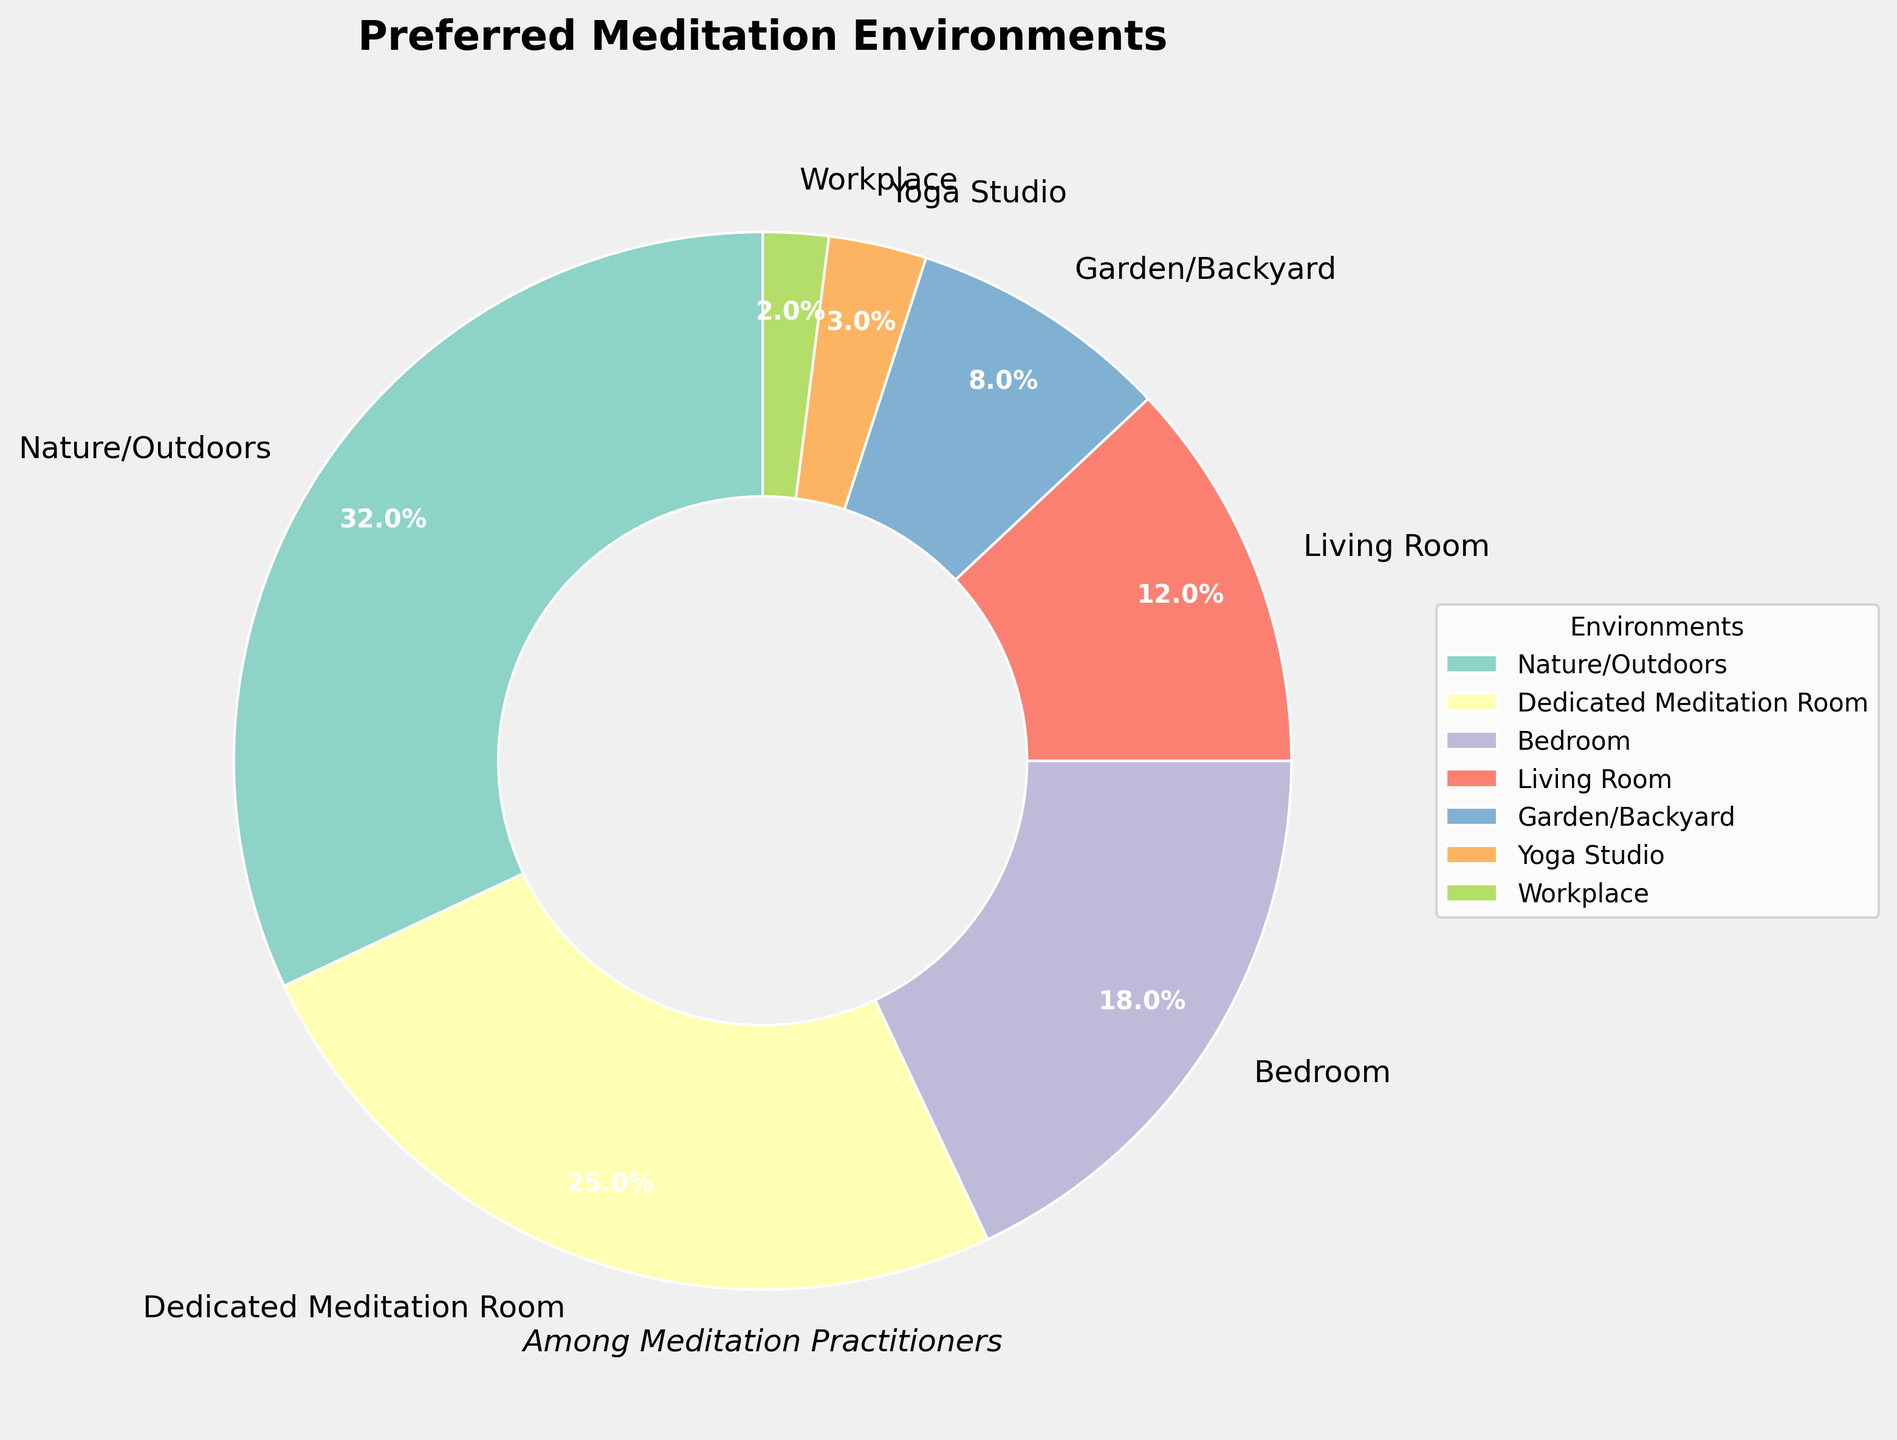Which meditation environment is preferred by the highest percentage of practitioners? The figure shows various meditation environments along with their corresponding percentages. The highest percentage is indicated by the largest slice of the pie chart.
Answer: Nature/Outdoors What is the combined percentage of practitioners who prefer meditating in their bedroom and living room? To find the combined percentage, sum the percentages of the 'Bedroom' and 'Living Room' slices. The figure shows these as 18% and 12%, respectively. So, 18% + 12% = 30%.
Answer: 30% Which is more popular, meditating in a garden/backyard or in a yoga studio? By comparing the sizes of the slices labeled 'Garden/Backyard' and 'Yoga Studio,' we can see that 'Garden/Backyard' is 8% and 'Yoga Studio' is 3%.
Answer: Garden/Backyard What is the difference in popularity between the least and most preferred meditation environments? The most preferred environment is 'Nature/Outdoors' at 32% and the least preferred is 'Workplace' at 2%. The difference is 32% - 2%.
Answer: 30% What percentage of practitioners prefer indoor environments for meditation? To find this, sum the percentages of indoor environments: 'Dedicated Meditation Room' (25%), 'Bedroom' (18%), 'Living Room' (12%), 'Yoga Studio' (3%), and 'Workplace' (2%). Therefore, 25% + 18% + 12% + 3% + 2% = 60%.
Answer: 60% How does the preference for a dedicated meditation room compare to the preference for a yoga studio? The slice for 'Dedicated Meditation Room' shows a percentage of 25%, whereas 'Yoga Studio' is 3%. This indicates that the dedicated meditation room is much more popular.
Answer: Dedicated Meditation Room is more popular by 22% How does the combined preference for nature/outdoors and garden/backyard compare to the combined preference for bedroom and living room? First, compute the combined preferences: Nature/Outdoors (32%) + Garden/Backyard (8%) = 40%; Bedroom (18%) + Living Room (12%) = 30%. Comparing these, 40% is greater than 30%.
Answer: Nature/Outdoors and Garden/Backyard Which environment is represented by the green slice, and what percentage does it hold? The description mentioned custom colors for slices. The green slice represents 'Yoga Studio,' and its label shows that it holds 3% of the total preference.
Answer: Yoga Studio, 3% Out of all the indoor environments listed (Dedicated Meditation Room, Bedroom, Living Room, Yoga Studio, Workplace), which holds the highest preference percentage and what is that percentage? The percentages for indoor environments are: Dedicated Meditation Room (25%), Bedroom (18%), Living Room (12%), Yoga Studio (3%), and Workplace (2%). The highest preference is for 'Dedicated Meditation Room' at 25%.
Answer: Dedicated Meditation Room, 25% 